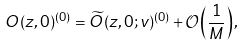Convert formula to latex. <formula><loc_0><loc_0><loc_500><loc_500>O ( z , 0 ) ^ { ( 0 ) } = \widetilde { O } ( z , 0 ; v ) ^ { ( 0 ) } + \mathcal { O } \left ( \frac { 1 } { M } \right ) ,</formula> 